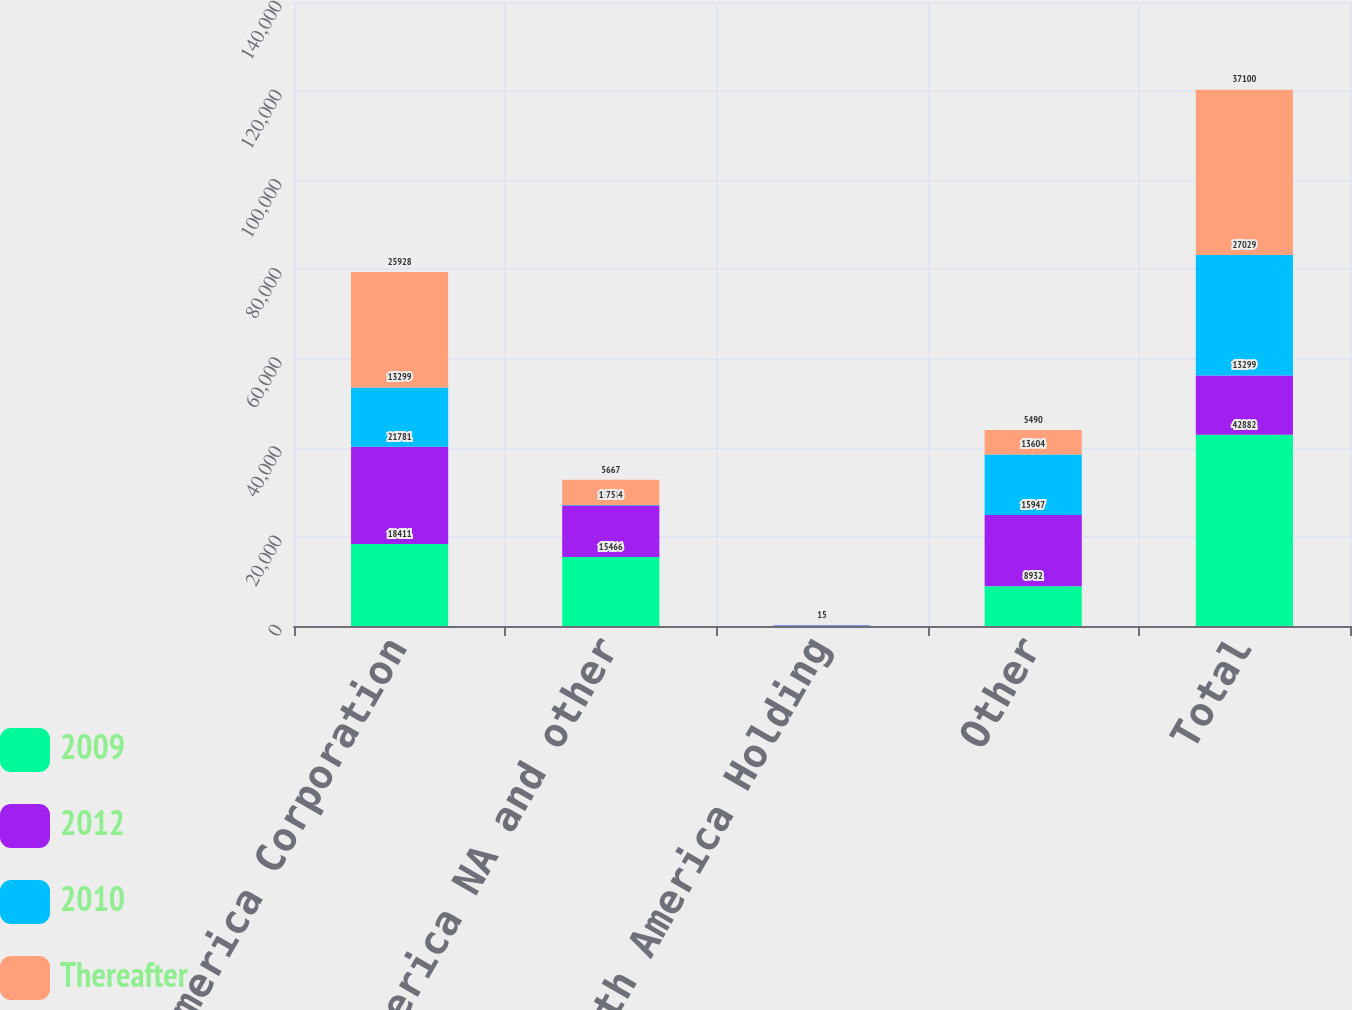Convert chart. <chart><loc_0><loc_0><loc_500><loc_500><stacked_bar_chart><ecel><fcel>Bank of America Corporation<fcel>Bank of America NA and other<fcel>BAC North America Holding<fcel>Other<fcel>Total<nl><fcel>2009<fcel>18411<fcel>15466<fcel>73<fcel>8932<fcel>42882<nl><fcel>2012<fcel>21781<fcel>11584<fcel>92<fcel>15947<fcel>13299<nl><fcel>2010<fcel>13299<fcel>75<fcel>51<fcel>13604<fcel>27029<nl><fcel>Thereafter<fcel>25928<fcel>5667<fcel>15<fcel>5490<fcel>37100<nl></chart> 